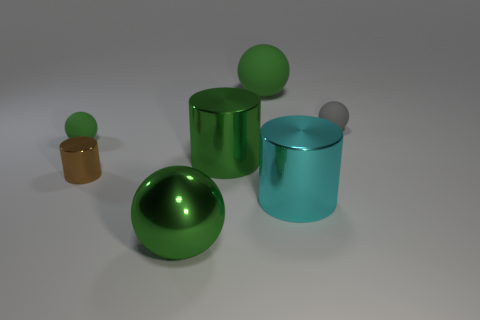Subtract all green balls. How many were subtracted if there are1green balls left? 2 Subtract all yellow cylinders. How many green balls are left? 3 Add 2 big cyan cylinders. How many objects exist? 9 Subtract all spheres. How many objects are left? 3 Subtract all green rubber spheres. Subtract all tiny gray matte balls. How many objects are left? 4 Add 6 tiny gray things. How many tiny gray things are left? 7 Add 7 large yellow metal balls. How many large yellow metal balls exist? 7 Subtract 0 blue cylinders. How many objects are left? 7 